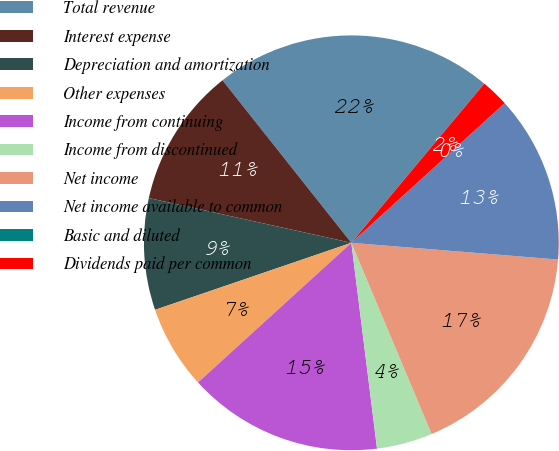Convert chart. <chart><loc_0><loc_0><loc_500><loc_500><pie_chart><fcel>Total revenue<fcel>Interest expense<fcel>Depreciation and amortization<fcel>Other expenses<fcel>Income from continuing<fcel>Income from discontinued<fcel>Net income<fcel>Net income available to common<fcel>Basic and diluted<fcel>Dividends paid per common<nl><fcel>21.74%<fcel>10.87%<fcel>8.7%<fcel>6.52%<fcel>15.22%<fcel>4.35%<fcel>17.39%<fcel>13.04%<fcel>0.0%<fcel>2.17%<nl></chart> 